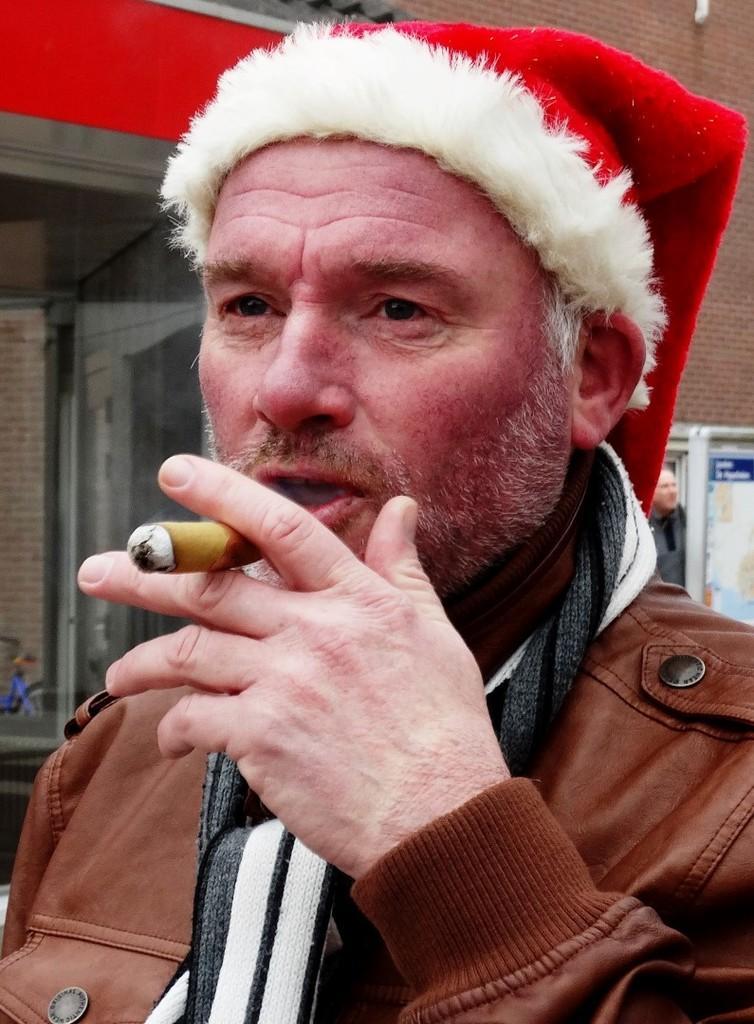Please provide a concise description of this image. In this image there is a person smoking, behind him there is a building, in front of the building there is another person standing. 